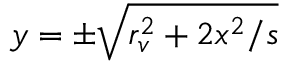<formula> <loc_0><loc_0><loc_500><loc_500>y = \pm \sqrt { r _ { v } ^ { 2 } + 2 x ^ { 2 } / s }</formula> 